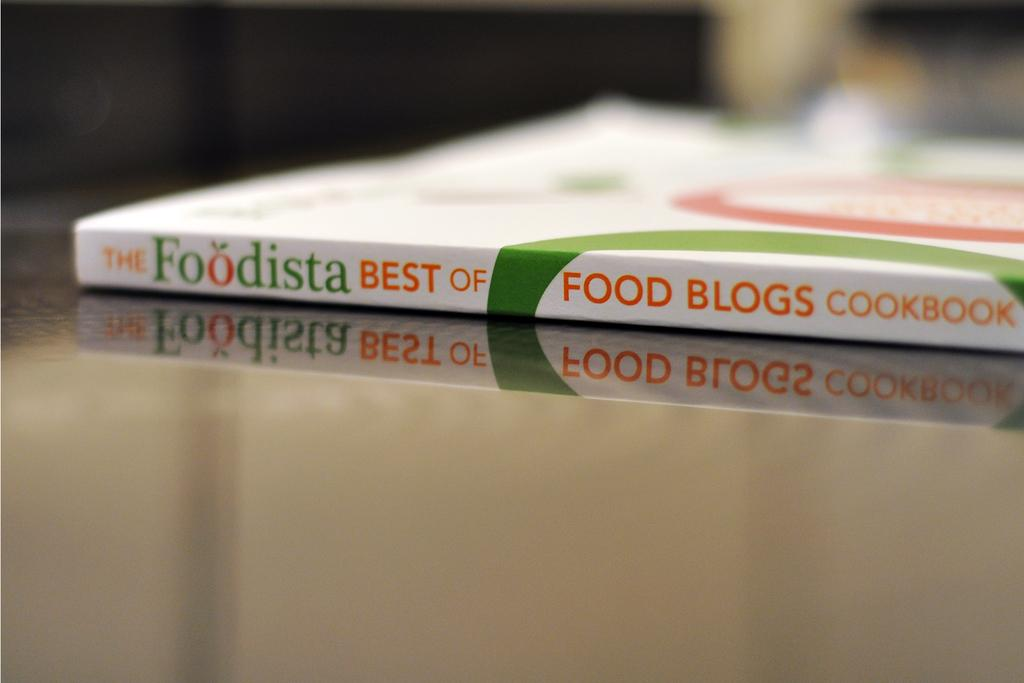<image>
Render a clear and concise summary of the photo. The book contains recipes that are supposedly the best of food blogs. 